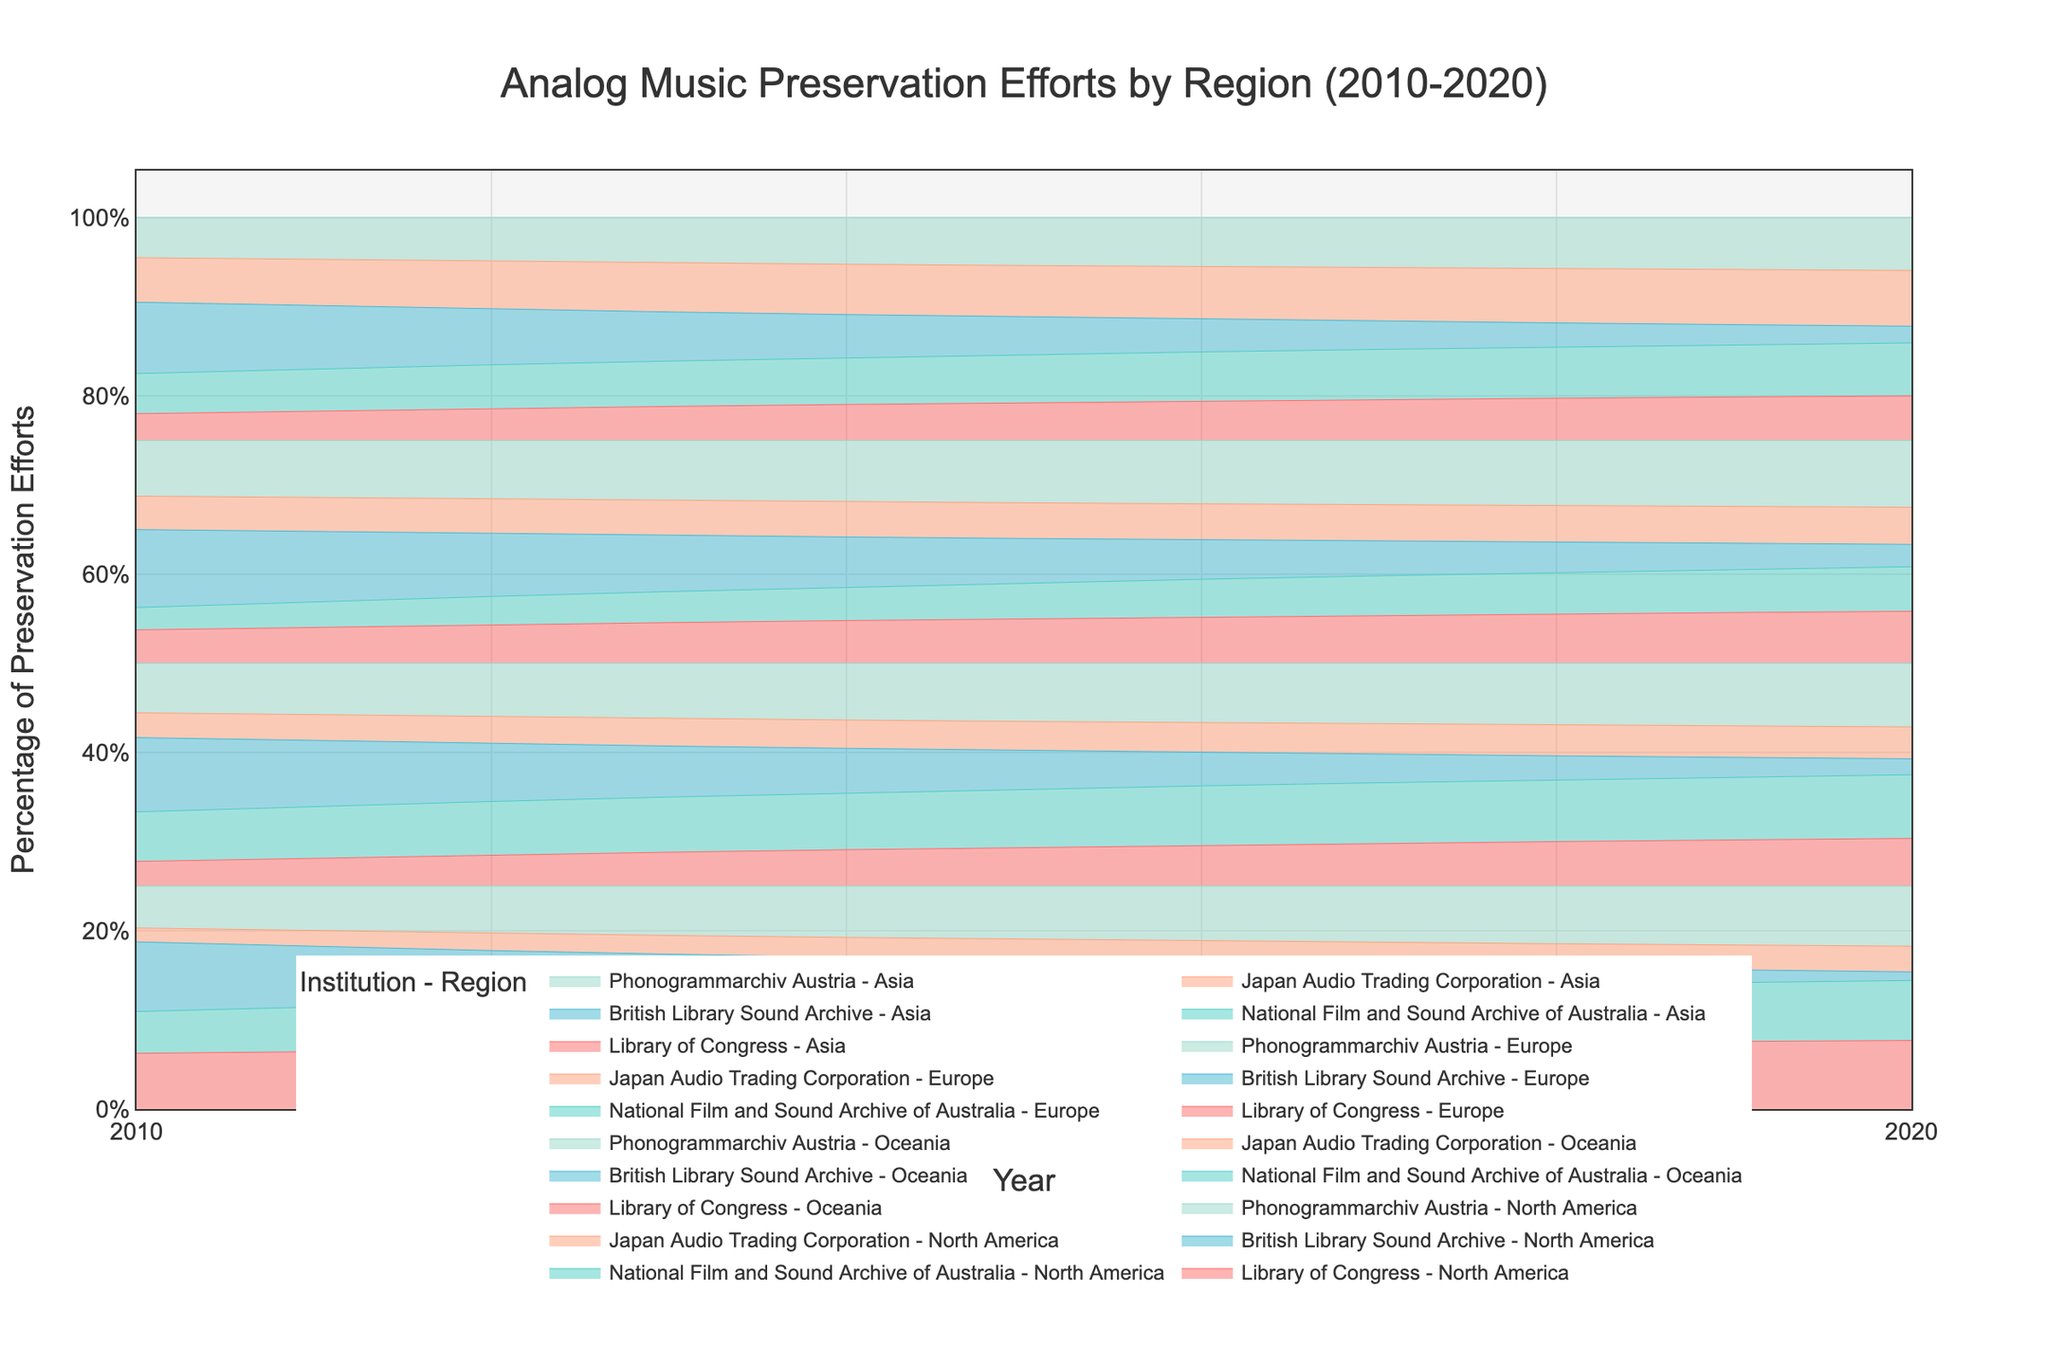What is the title of the figure? The title of the figure is typically located at the top center of the graph and summarises the main topic of the chart.
Answer: Analog Music Preservation Efforts by Region (2010-2020) Which region shows the highest percentage of preservation efforts by the Library of Congress in 2020? To find this information, locate the segment corresponding to the Library of Congress for the year 2020 in the stacked area chart.
Answer: North America How did the preservation efforts by the British Library Sound Archive change from 2010 to 2020 in North America? Compare the position of the segment for the British Library Sound Archive in North America from 2010 to 2020 to see how its percentage of contribution evolves over time.
Answer: It decreased Which region had a higher percentage of preservation efforts by the National Film and Sound Archive of Australia in 2015: Oceania or Europe? Check the percentage representation of the National Film and Sound Archive of Australia for both Oceania and Europe in the year 2015 and compare them.
Answer: Oceania What is the general trend for preservation efforts by the Japan Audio Trading Corporation in Asia from 2010 to 2020? Observe the area proportion of Japan Audio Trading Corporation in Asia across the years 2010 to 2020 to identify whether it is increasing, decreasing, or remaining constant.
Answer: Increasing In 2017, which institution had a larger contribution to preservation efforts in Europe: Phonogrammarchiv Austria or Library of Congress? Compare the areas of Phonogrammarchiv Austria and Library of Congress in Europe for the year 2017.
Answer: Phonogrammarchiv Austria What was the trend in preservation efforts by Phonogrammarchiv Austria in Oceania from 2010 to 2020? By examining the size of the area assigned to Phonogrammarchiv Austria in Oceania from 2010 to 2020, we can identify whether the trend is increasing, decreasing, or stable.
Answer: Increasing Are there any years where the percentage preservation efforts by National Film and Sound Archive of Australia in North America is exactly 20%? Check each year for North America to see if the area representing National Film and Sound Archive of Australia reaches exactly 20%.
Answer: No Which institution had the smallest percentage of preservation efforts in North America in 2015? Identify the smallest area among the segments for the year 2015 in North America.
Answer: British Library Sound Archive 